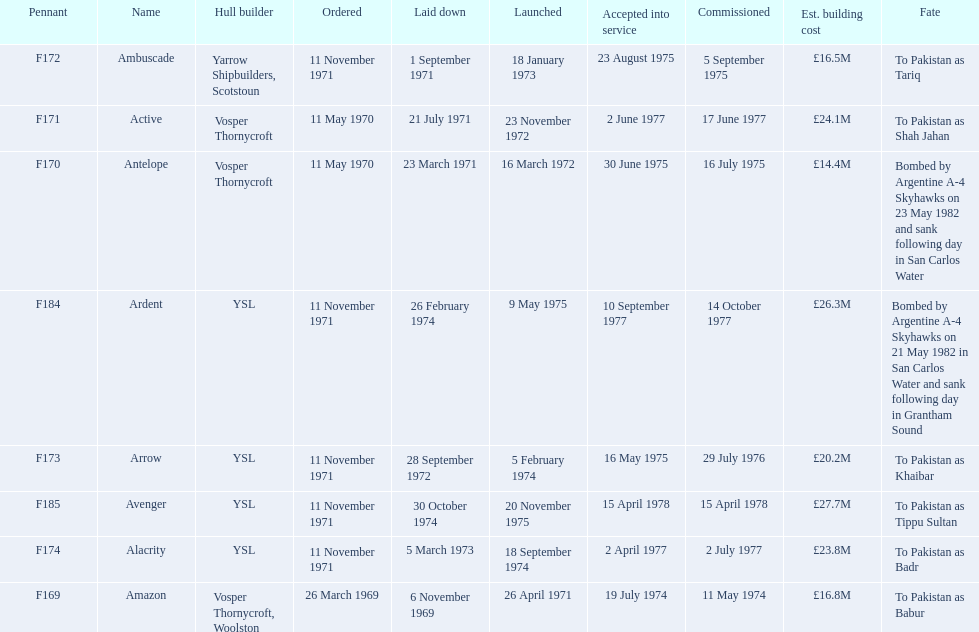Which ship was commissioned before the arrow on november 11, 1971? Ambuscade. 